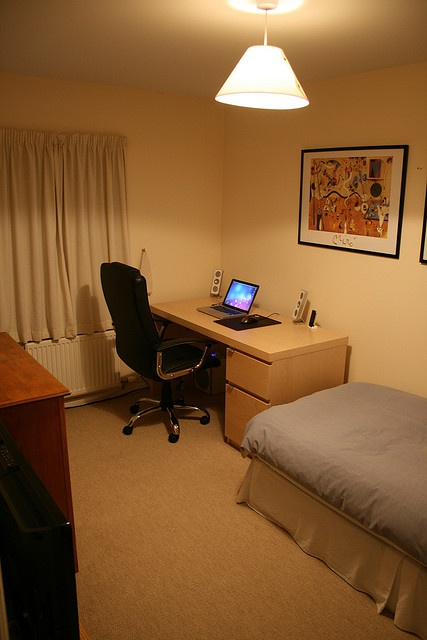Describe the objects in this image and their specific colors. I can see bed in maroon, gray, and tan tones, chair in maroon, black, and brown tones, laptop in maroon, black, olive, and lightblue tones, and mouse in maroon, black, and brown tones in this image. 